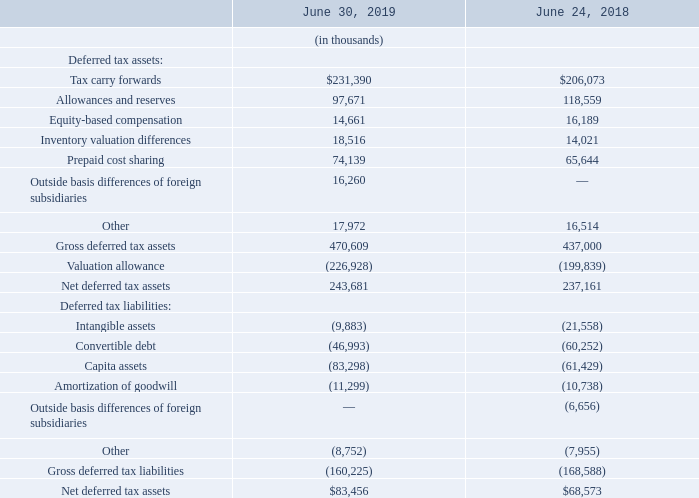Deferred income taxes reflect the net tax effect of temporary differences between the carrying amounts of assets and liabilities for financial reporting purposes and the amounts used for income tax purposes, as well as the tax effect of carryforwards. Significant components of the Company’s net deferred tax assets and liabilities were as follows:
The increase in the gross deferred tax assets and valuation allowance between fiscal year 2019 and 2018 is primarily due to increases in tax carryforwards.
Realization of the Company’s net deferred tax assets is based upon the weighting of available evidence, including such factors as the recent earnings history and expected future taxable income. The Company believes it is more likely than not that such deferred tax assets will be realized with the exception of $227.0 million primarily related to California deferred tax assets. At June 30, 2019, the Company continued to record a valuation allowance to offset the entire California deferred tax asset balance due to the single sales factor apportionment resulting in lower taxable income in California.
At June 30, 2019, the Company had federal net operating loss carryforwards of $109.8 million. The majority of these losses will begin to expire in fiscal year 2020, and are subject to limitation on their utilization.
At June 30, 2019, the Company had state net operating loss carryforwards of $58.5 million. If not utilized, these losses will begin to expire in fiscal year 2020 and are subject to limitation on their utilization.
At June 30, 2019, the Company had state tax credit carryforwards of $322.4 million. Substantially all of these credits can be carried forward indefinitely.
What was the amount of federal net operating loss carryforwards at June 30, 2019? $109.8 million. What was the amount of state net operating loss carryforwards at June 30, 2019? $58.5 million. What was the amount of state tax credit carryforwards at June 30, 2019? $322.4 million. What is the percentage change in the tax carry forwards from 2018 to 2019?
Answer scale should be: percent. (231,390-206,073)/206,073
Answer: 12.29. What is the percentage change in the gross deferred tax assets from 2018 to 2019?
Answer scale should be: percent. (470,609-437,000)/437,000
Answer: 7.69. In which year is the net deferred tax assets higher? Find the year with the higher net deferred tax assets
Answer: 2019. 